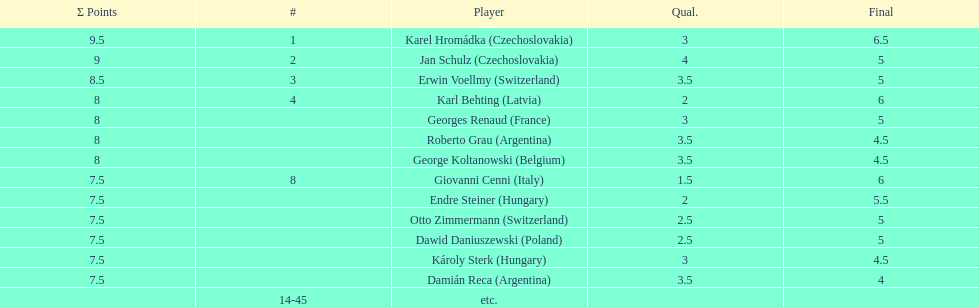From switzerland, who scored the most points? Erwin Voellmy. 